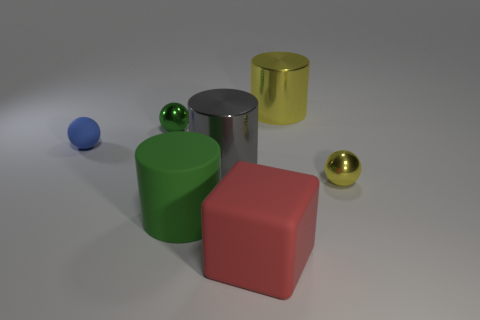There is a green object in front of the small ball left of the tiny metal sphere that is on the left side of the large red rubber object; what is its material?
Make the answer very short. Rubber. What number of spheres are green matte objects or green shiny objects?
Your answer should be compact. 1. The tiny shiny sphere that is left of the yellow metallic cylinder is what color?
Keep it short and to the point. Green. How many rubber things are gray balls or red cubes?
Provide a short and direct response. 1. There is a ball that is behind the sphere on the left side of the green metallic sphere; what is it made of?
Make the answer very short. Metal. What color is the big matte cube?
Give a very brief answer. Red. There is a large metal cylinder that is left of the red rubber block; is there a metallic cylinder to the right of it?
Offer a very short reply. Yes. What is the small blue thing made of?
Offer a terse response. Rubber. Is the material of the small ball to the right of the red rubber thing the same as the small thing behind the tiny blue matte thing?
Provide a short and direct response. Yes. Are there any other things that have the same color as the matte cylinder?
Keep it short and to the point. Yes. 